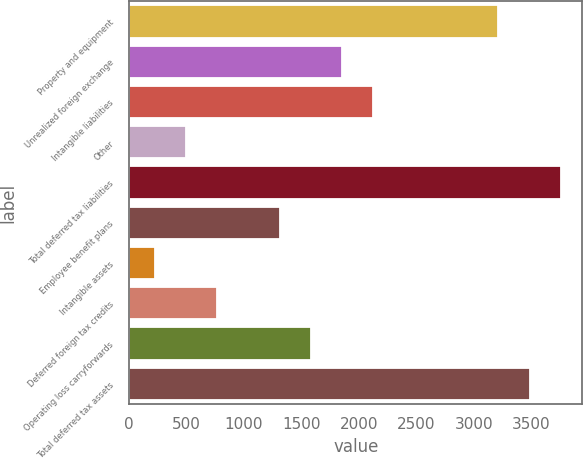Convert chart. <chart><loc_0><loc_0><loc_500><loc_500><bar_chart><fcel>Property and equipment<fcel>Unrealized foreign exchange<fcel>Intangible liabilities<fcel>Other<fcel>Total deferred tax liabilities<fcel>Employee benefit plans<fcel>Intangible assets<fcel>Deferred foreign tax credits<fcel>Operating loss carryforwards<fcel>Total deferred tax assets<nl><fcel>3212.29<fcel>1853.34<fcel>2125.13<fcel>494.39<fcel>3755.87<fcel>1309.76<fcel>222.6<fcel>766.18<fcel>1581.55<fcel>3484.08<nl></chart> 